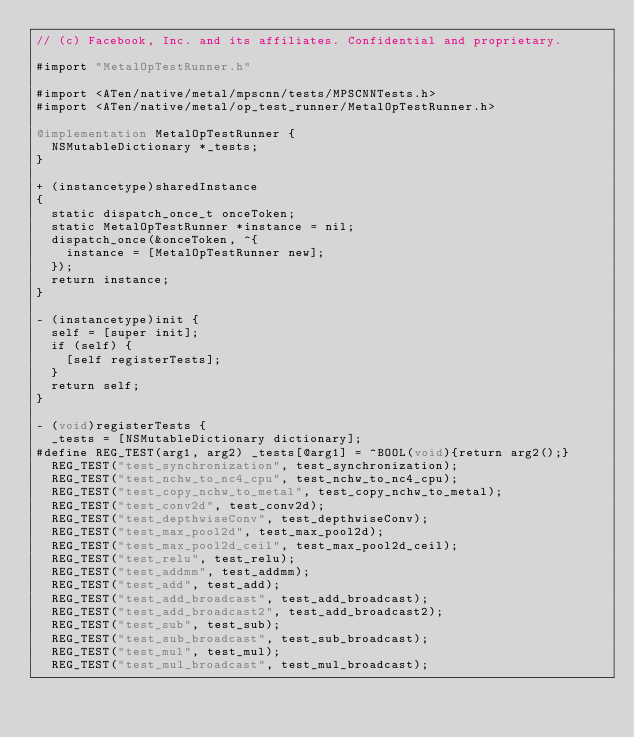Convert code to text. <code><loc_0><loc_0><loc_500><loc_500><_ObjectiveC_>// (c) Facebook, Inc. and its affiliates. Confidential and proprietary.

#import "MetalOpTestRunner.h"

#import <ATen/native/metal/mpscnn/tests/MPSCNNTests.h>
#import <ATen/native/metal/op_test_runner/MetalOpTestRunner.h>

@implementation MetalOpTestRunner {
  NSMutableDictionary *_tests;
}

+ (instancetype)sharedInstance
{
  static dispatch_once_t onceToken;
  static MetalOpTestRunner *instance = nil;
  dispatch_once(&onceToken, ^{
    instance = [MetalOpTestRunner new];
  });
  return instance;
}

- (instancetype)init {
  self = [super init];
  if (self) {
    [self registerTests];
  }
  return self;
}

- (void)registerTests {
  _tests = [NSMutableDictionary dictionary];
#define REG_TEST(arg1, arg2) _tests[@arg1] = ^BOOL(void){return arg2();}
  REG_TEST("test_synchronization", test_synchronization);
  REG_TEST("test_nchw_to_nc4_cpu", test_nchw_to_nc4_cpu);
  REG_TEST("test_copy_nchw_to_metal", test_copy_nchw_to_metal);
  REG_TEST("test_conv2d", test_conv2d);
  REG_TEST("test_depthwiseConv", test_depthwiseConv);
  REG_TEST("test_max_pool2d", test_max_pool2d);
  REG_TEST("test_max_pool2d_ceil", test_max_pool2d_ceil);
  REG_TEST("test_relu", test_relu);
  REG_TEST("test_addmm", test_addmm);
  REG_TEST("test_add", test_add);
  REG_TEST("test_add_broadcast", test_add_broadcast);
  REG_TEST("test_add_broadcast2", test_add_broadcast2);
  REG_TEST("test_sub", test_sub);
  REG_TEST("test_sub_broadcast", test_sub_broadcast);
  REG_TEST("test_mul", test_mul);
  REG_TEST("test_mul_broadcast", test_mul_broadcast);</code> 